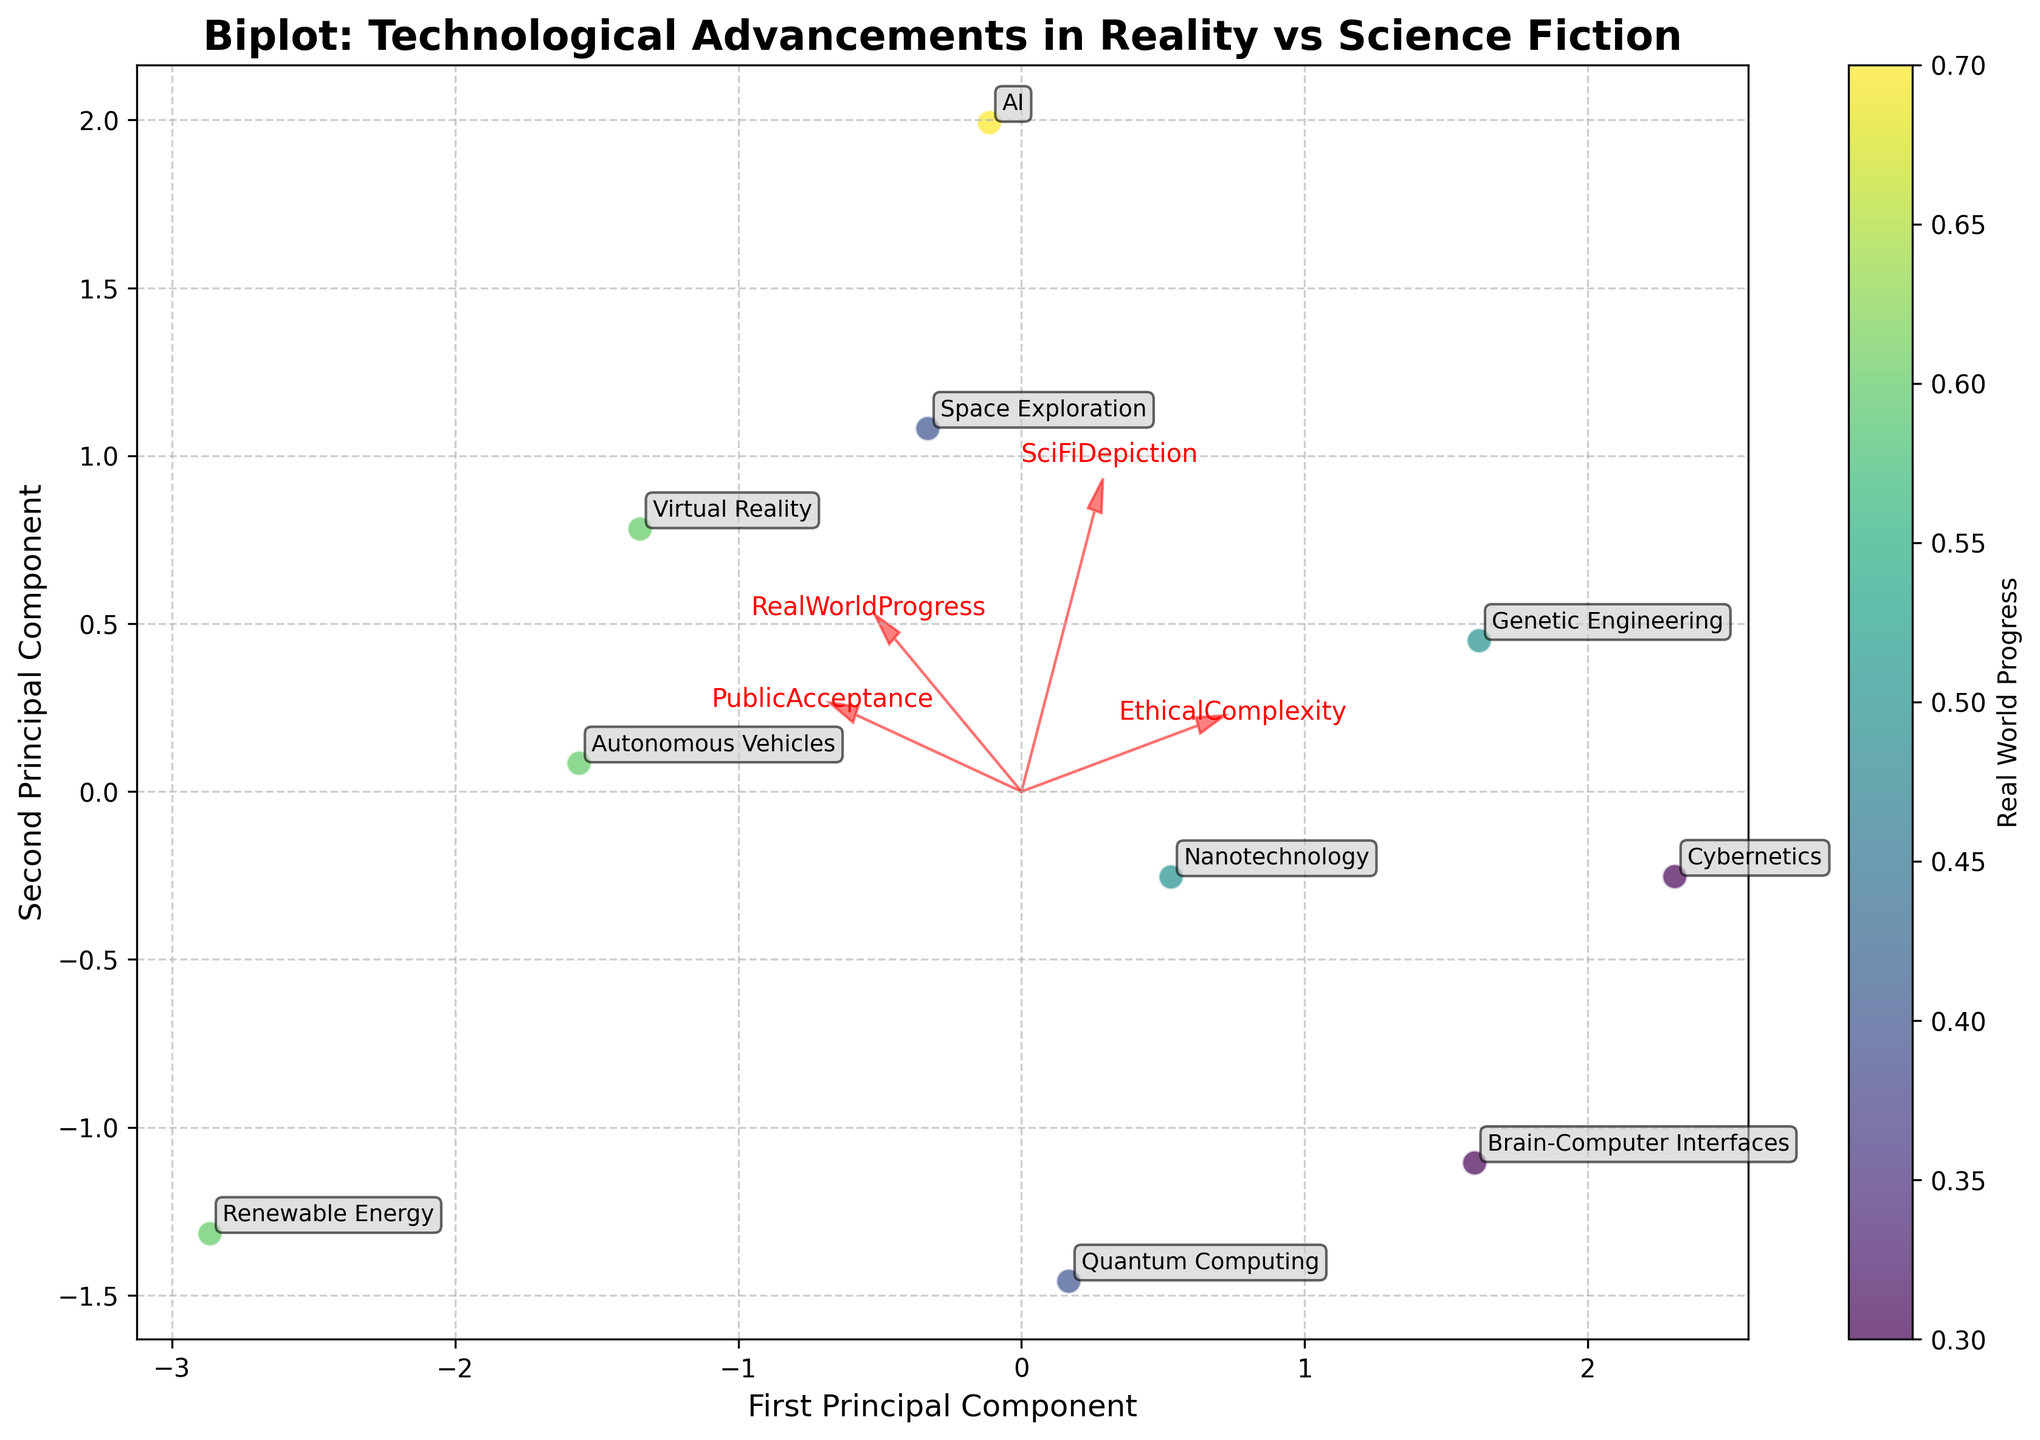Which technology is depicted as having the highest ethical complexity in science fiction? To identify this, look for the point closest to the vector representing 'EthicalComplexity'. The data point for 'Genetic Engineering' is closest.
Answer: Genetic Engineering What feature vector direction does most of 'Real World Progress' correlate with? The 'RealWorldProgress' feature vector points to the right along the first principal component.
Answer: First Principal Component Which technology has the highest real-world progress value? Refer to the color intensity of the scatter points. The darkest color, indicating the highest real-world progress value, corresponds to 'AI'.
Answer: AI How does public acceptance correlate with ethical complexity in the plot? By observing the directions of the 'PublicAcceptance' and 'EthicalComplexity' vectors, one can see that they point in nearly opposite directions, indicating a negative correlation.
Answer: Negative correlation Which technologies have similar PCA coordinates but differ significantly in their real-world progress? 'Virtual Reality' and 'Autonomous Vehicles' appear close to each other in PCA space but differ in color, indicating different real-world progress values.
Answer: Virtual Reality and Autonomous Vehicles How does space exploration in science fiction compare to its real-world progress? Space Exploration is positioned leftward along the first principal component (lower real-world progress) but upward along the second (high sci-fi depiction).
Answer: Low real-world progress, high sci-fi depiction Which technology shows high public acceptance but moderate to low ethical complexity in science fiction? 'Renewable Energy' is located close to the 'PublicAcceptance' vector and further from the 'EthicalComplexity' vector.
Answer: Renewable Energy What technology is most closely aligned with the combination of the four feature vectors? The technology closest to the origin (0, 0) in the PCA plot represents a balanced combination, which appears to be 'Autonomous Vehicles'.
Answer: Autonomous Vehicles In which principal components are the majority of the data points primarily distributed? Most data points are distributed along the first and second principal components, as evidenced by their positions in the plot.
Answer: First and Second Principal Components 